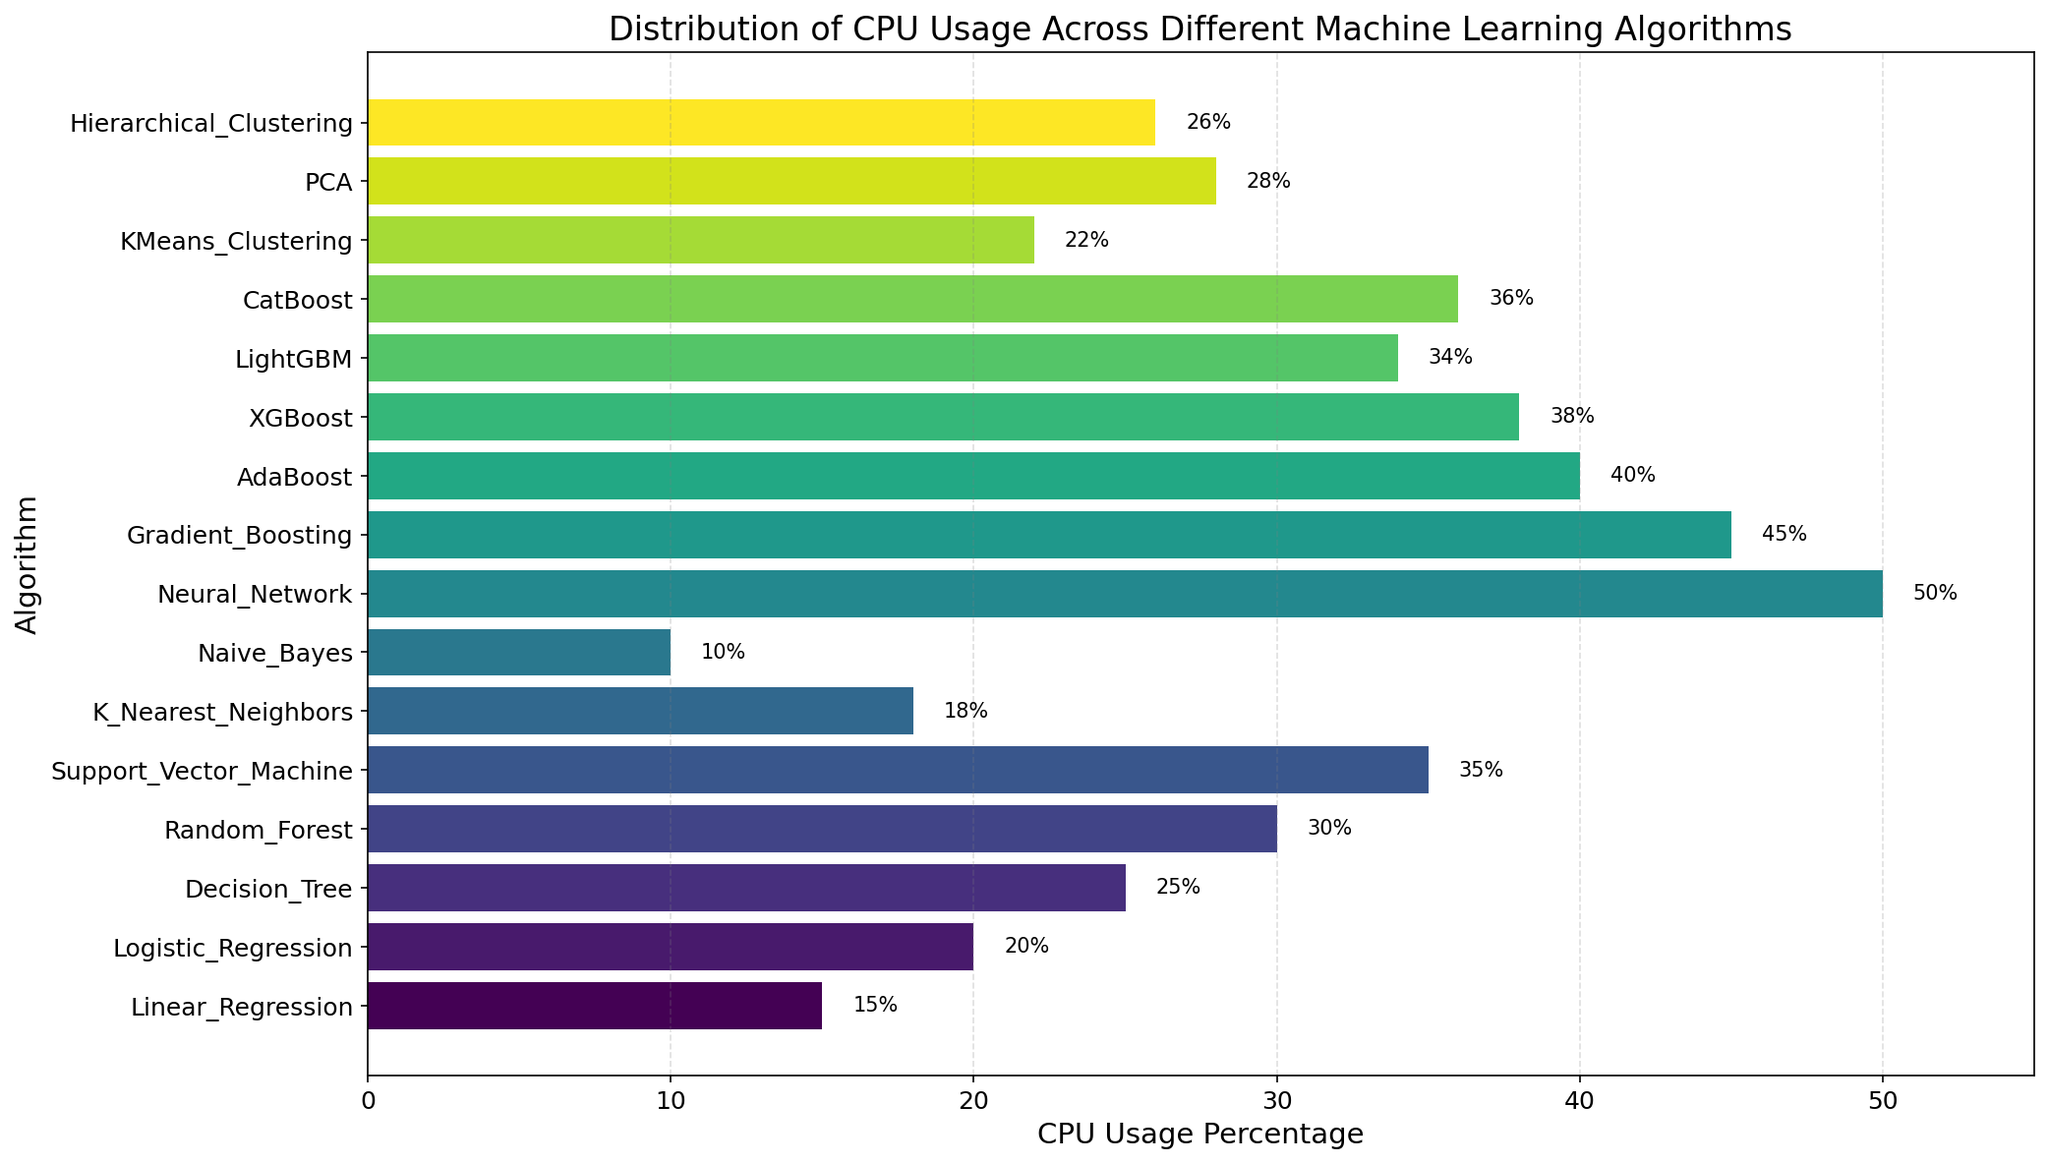Which algorithm has the highest CPU usage percentage? The highest bar in the chart represents Neural Network, and its data label shows 50%.
Answer: Neural Network How much more CPU usage does Random Forest have compared to K Nearest Neighbors? From the chart, Random Forest uses 30%, and K Nearest Neighbors uses 18%. The difference is 30% - 18% = 12%.
Answer: 12% What is the average CPU usage of Decision Tree and PCA? Decision Tree uses 25% and PCA uses 28%. The sum is 25% + 28% = 53%, and the average is 53% / 2 = 26.5%.
Answer: 26.5% Which algorithm uses less CPU: AdaBoost or XGBoost, and by how much? AdaBoost uses 40% while XGBoost uses 38%. The difference is 40% - 38% = 2%.
Answer: XGBoost, 2% What is the total CPU usage percentage for Gradient Boosting, LightGBM, and CatBoost? Gradient Boosting uses 45%, LightGBM uses 34%, and CatBoost uses 36%. The total is 45% + 34% + 36% = 115%.
Answer: 115% Which algorithm has a lower CPU usage: Logistic Regression or Hierarchical Clustering? The bar for Logistic Regression is at 20%, while the bar for Hierarchical Clustering is at 26%.
Answer: Logistic Regression What is the median CPU usage percentage for all algorithms? Ordering the CPU usage values: 10, 15, 18, 20, 22, 25, 26, 28, 30, 34, 35, 36, 38, 40, 45, 50. There are 16 values, so the median is the average of the 8th and 9th values which are 28 and 30. The median is (28 + 30) / 2 = 29%.
Answer: 29% Which color is associated with Neural Network in the bar chart? The color associated with Neural Network is the last in the gradient because it's the highest CPU usage bar. This color is likely the darkest in the 'viridis' color map.
Answer: Darkest color By how much does LightGBM's CPU usage exceed the CPU usage of Naive Bayes? LightGBM uses 34%, while Naive Bayes uses 10%. The difference is 34% - 10% = 24%.
Answer: 24% How does CPU usage of KMeans Clustering compare to Support Vector Machine? KMeans Clustering uses 22%, while Support Vector Machine uses 35%. KMeans Clustering uses less CPU than Support Vector Machine by 35% - 22% = 13%.
Answer: KMeans Clustering uses 13% less CPU 